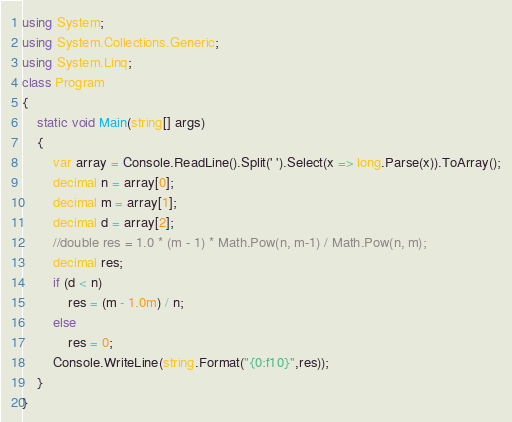Convert code to text. <code><loc_0><loc_0><loc_500><loc_500><_C#_>using System;
using System.Collections.Generic;
using System.Linq;
class Program
{
    static void Main(string[] args)
    {
        var array = Console.ReadLine().Split(' ').Select(x => long.Parse(x)).ToArray();
        decimal n = array[0];
        decimal m = array[1];
        decimal d = array[2];
        //double res = 1.0 * (m - 1) * Math.Pow(n, m-1) / Math.Pow(n, m);
        decimal res;
        if (d < n)
            res = (m - 1.0m) / n;
        else
            res = 0;
        Console.WriteLine(string.Format("{0:f10}",res));
    }
}
</code> 